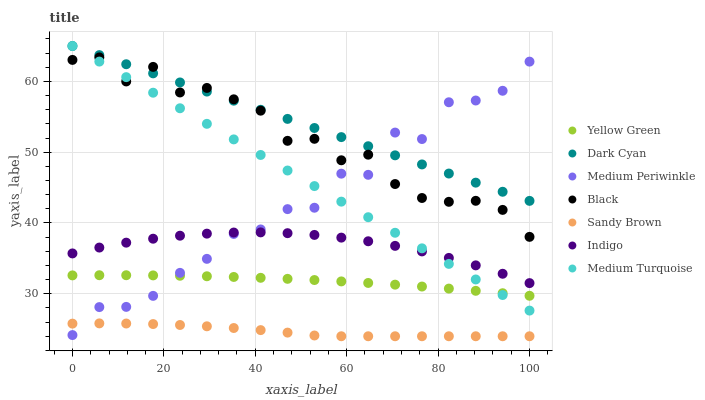Does Sandy Brown have the minimum area under the curve?
Answer yes or no. Yes. Does Dark Cyan have the maximum area under the curve?
Answer yes or no. Yes. Does Yellow Green have the minimum area under the curve?
Answer yes or no. No. Does Yellow Green have the maximum area under the curve?
Answer yes or no. No. Is Dark Cyan the smoothest?
Answer yes or no. Yes. Is Medium Periwinkle the roughest?
Answer yes or no. Yes. Is Yellow Green the smoothest?
Answer yes or no. No. Is Yellow Green the roughest?
Answer yes or no. No. Does Sandy Brown have the lowest value?
Answer yes or no. Yes. Does Yellow Green have the lowest value?
Answer yes or no. No. Does Dark Cyan have the highest value?
Answer yes or no. Yes. Does Yellow Green have the highest value?
Answer yes or no. No. Is Sandy Brown less than Dark Cyan?
Answer yes or no. Yes. Is Dark Cyan greater than Yellow Green?
Answer yes or no. Yes. Does Medium Turquoise intersect Yellow Green?
Answer yes or no. Yes. Is Medium Turquoise less than Yellow Green?
Answer yes or no. No. Is Medium Turquoise greater than Yellow Green?
Answer yes or no. No. Does Sandy Brown intersect Dark Cyan?
Answer yes or no. No. 